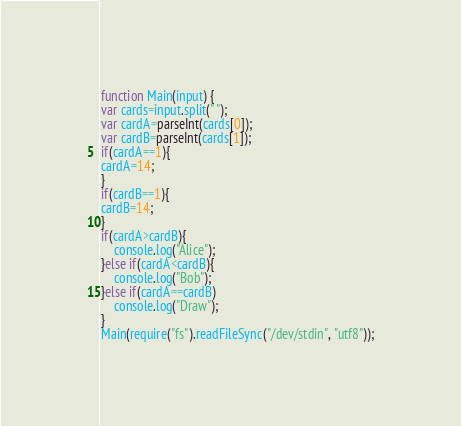<code> <loc_0><loc_0><loc_500><loc_500><_JavaScript_>function Main(input) {
var cards=input.split(" ");
var cardA=parseInt(cards[0]);
var cardB=parseInt(cards[1]);
if(cardA==1){
cardA=14;
}
if(cardB==1){
cardB=14;
}
if(cardA>cardB){
	console.log("Alice");
}else if(cardA<cardB){
	console.log("Bob");
}else if(cardA==cardB)
	console.log("Draw");
}
Main(require("fs").readFileSync("/dev/stdin", "utf8"));</code> 